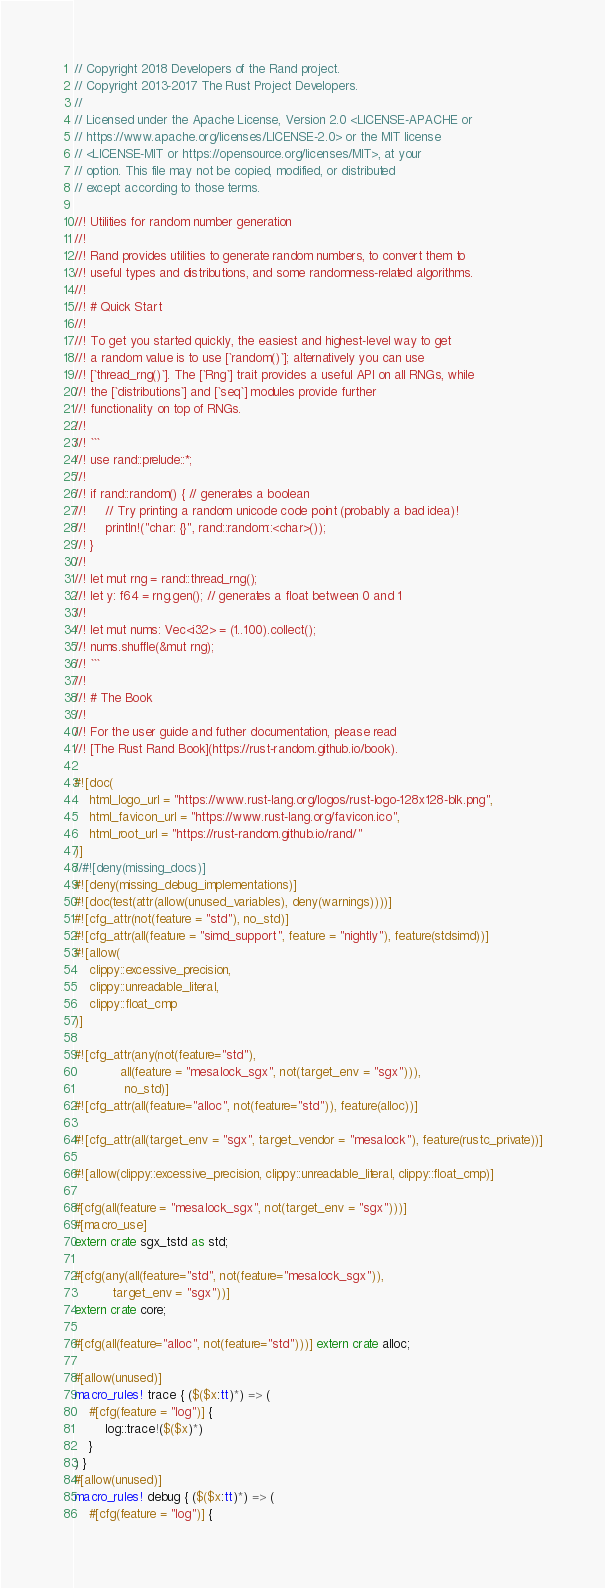Convert code to text. <code><loc_0><loc_0><loc_500><loc_500><_Rust_>// Copyright 2018 Developers of the Rand project.
// Copyright 2013-2017 The Rust Project Developers.
//
// Licensed under the Apache License, Version 2.0 <LICENSE-APACHE or
// https://www.apache.org/licenses/LICENSE-2.0> or the MIT license
// <LICENSE-MIT or https://opensource.org/licenses/MIT>, at your
// option. This file may not be copied, modified, or distributed
// except according to those terms.

//! Utilities for random number generation
//!
//! Rand provides utilities to generate random numbers, to convert them to
//! useful types and distributions, and some randomness-related algorithms.
//!
//! # Quick Start
//!
//! To get you started quickly, the easiest and highest-level way to get
//! a random value is to use [`random()`]; alternatively you can use
//! [`thread_rng()`]. The [`Rng`] trait provides a useful API on all RNGs, while
//! the [`distributions`] and [`seq`] modules provide further
//! functionality on top of RNGs.
//!
//! ```
//! use rand::prelude::*;
//!
//! if rand::random() { // generates a boolean
//!     // Try printing a random unicode code point (probably a bad idea)!
//!     println!("char: {}", rand::random::<char>());
//! }
//!
//! let mut rng = rand::thread_rng();
//! let y: f64 = rng.gen(); // generates a float between 0 and 1
//!
//! let mut nums: Vec<i32> = (1..100).collect();
//! nums.shuffle(&mut rng);
//! ```
//!
//! # The Book
//!
//! For the user guide and futher documentation, please read
//! [The Rust Rand Book](https://rust-random.github.io/book).

#![doc(
    html_logo_url = "https://www.rust-lang.org/logos/rust-logo-128x128-blk.png",
    html_favicon_url = "https://www.rust-lang.org/favicon.ico",
    html_root_url = "https://rust-random.github.io/rand/"
)]
//#![deny(missing_docs)]
#![deny(missing_debug_implementations)]
#![doc(test(attr(allow(unused_variables), deny(warnings))))]
#![cfg_attr(not(feature = "std"), no_std)]
#![cfg_attr(all(feature = "simd_support", feature = "nightly"), feature(stdsimd))]
#![allow(
    clippy::excessive_precision,
    clippy::unreadable_literal,
    clippy::float_cmp
)]

#![cfg_attr(any(not(feature="std"),
            all(feature = "mesalock_sgx", not(target_env = "sgx"))),
             no_std)]
#![cfg_attr(all(feature="alloc", not(feature="std")), feature(alloc))]

#![cfg_attr(all(target_env = "sgx", target_vendor = "mesalock"), feature(rustc_private))]

#![allow(clippy::excessive_precision, clippy::unreadable_literal, clippy::float_cmp)]

#[cfg(all(feature = "mesalock_sgx", not(target_env = "sgx")))]
#[macro_use]
extern crate sgx_tstd as std;

#[cfg(any(all(feature="std", not(feature="mesalock_sgx")),
          target_env = "sgx"))]
extern crate core;

#[cfg(all(feature="alloc", not(feature="std")))] extern crate alloc;

#[allow(unused)]
macro_rules! trace { ($($x:tt)*) => (
    #[cfg(feature = "log")] {
        log::trace!($($x)*)
    }
) }
#[allow(unused)]
macro_rules! debug { ($($x:tt)*) => (
    #[cfg(feature = "log")] {</code> 